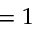Convert formula to latex. <formula><loc_0><loc_0><loc_500><loc_500>= 1</formula> 